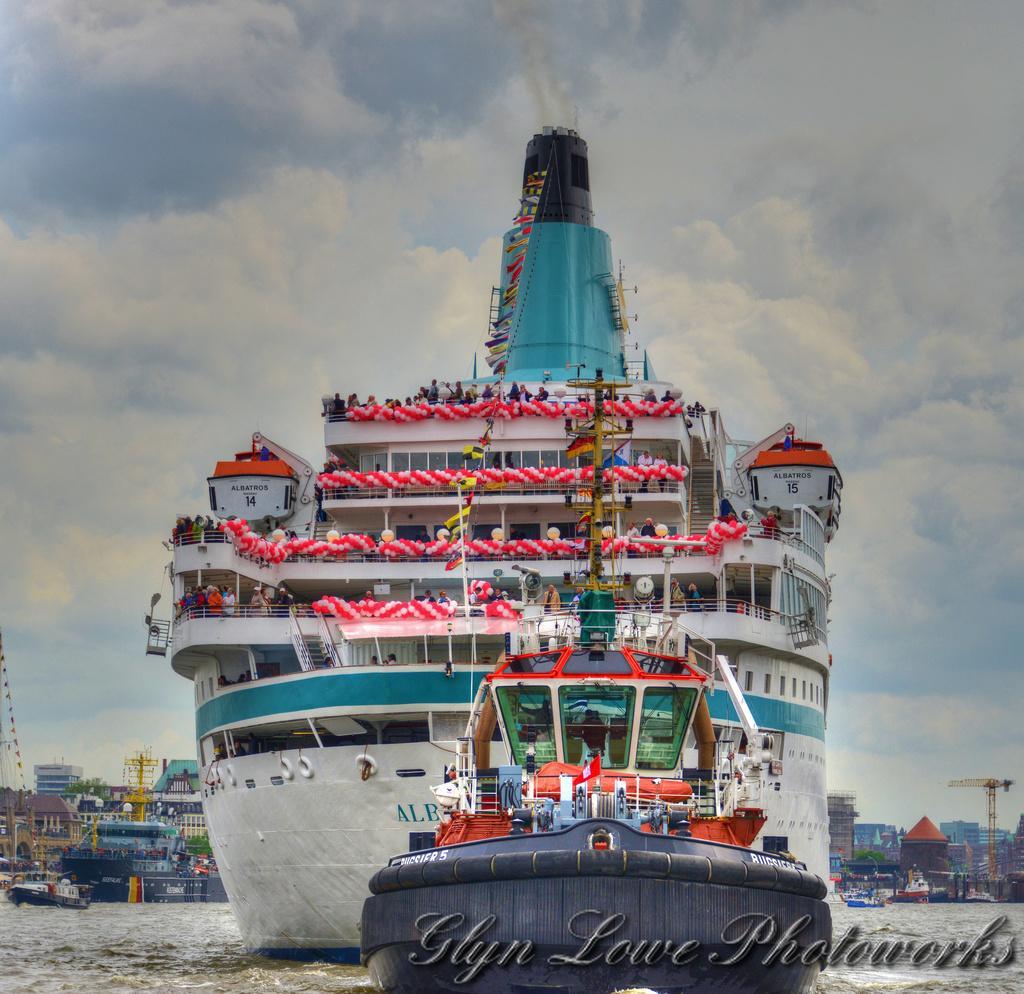Please provide a concise description of this image. In this image we can see ships on water, construction cranes, buildings and sky with clouds in the background. 